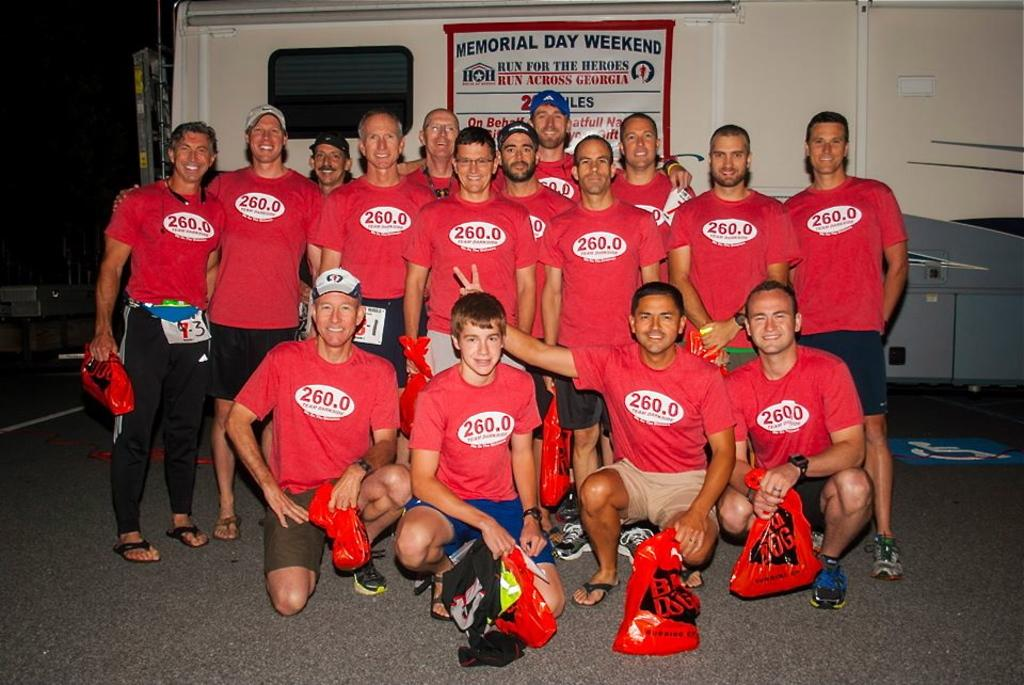<image>
Summarize the visual content of the image. A group of people all with 260.0 on their red shirts stand in front of a Memorial Day Weekend fun run poster. 